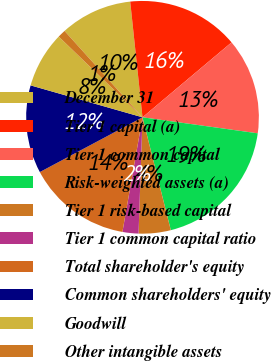Convert chart. <chart><loc_0><loc_0><loc_500><loc_500><pie_chart><fcel>December 31<fcel>Tier 1 capital (a)<fcel>Tier 1 common capital<fcel>Risk-weighted assets (a)<fcel>Tier 1 risk-based capital<fcel>Tier 1 common capital ratio<fcel>Total shareholder's equity<fcel>Common shareholders' equity<fcel>Goodwill<fcel>Other intangible assets<nl><fcel>10.0%<fcel>15.55%<fcel>13.33%<fcel>18.89%<fcel>4.45%<fcel>2.22%<fcel>14.44%<fcel>12.22%<fcel>7.78%<fcel>1.11%<nl></chart> 